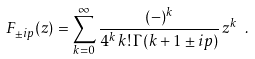<formula> <loc_0><loc_0><loc_500><loc_500>F _ { \pm i p } ( z ) = \sum _ { k = 0 } ^ { \infty } \frac { ( - ) ^ { k } } { 4 ^ { k } \, k ! \, \Gamma ( k + 1 \pm i p ) } \, z ^ { k } \ .</formula> 